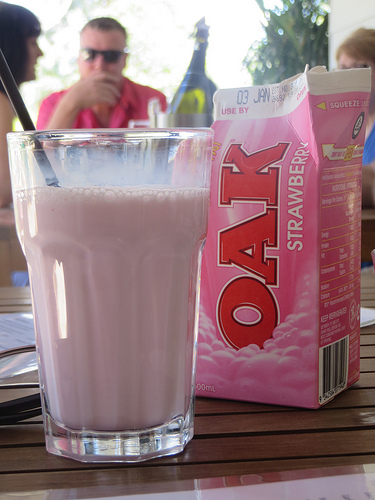<image>
Is the glass behind the cooling glass? No. The glass is not behind the cooling glass. From this viewpoint, the glass appears to be positioned elsewhere in the scene. 